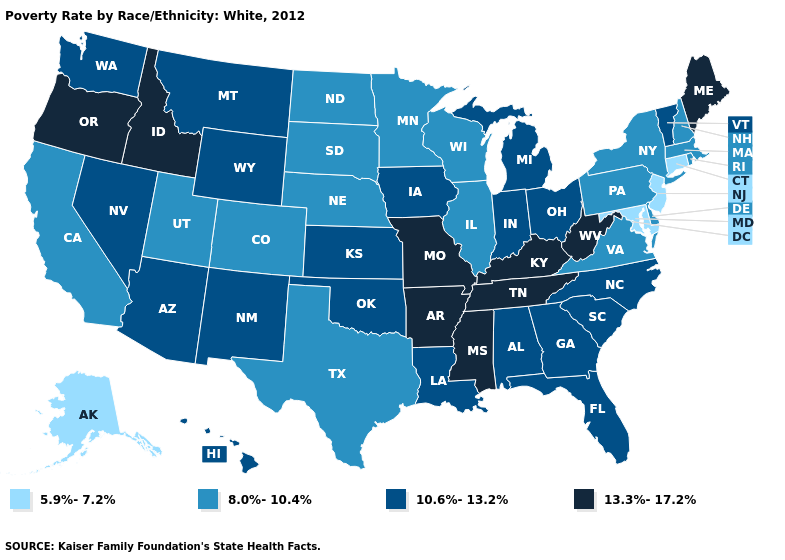Does New Jersey have the lowest value in the USA?
Keep it brief. Yes. Among the states that border Illinois , which have the lowest value?
Answer briefly. Wisconsin. Does Illinois have the same value as Louisiana?
Be succinct. No. Does Louisiana have the highest value in the USA?
Be succinct. No. What is the lowest value in states that border Ohio?
Quick response, please. 8.0%-10.4%. Name the states that have a value in the range 10.6%-13.2%?
Keep it brief. Alabama, Arizona, Florida, Georgia, Hawaii, Indiana, Iowa, Kansas, Louisiana, Michigan, Montana, Nevada, New Mexico, North Carolina, Ohio, Oklahoma, South Carolina, Vermont, Washington, Wyoming. What is the value of Michigan?
Write a very short answer. 10.6%-13.2%. Which states have the highest value in the USA?
Answer briefly. Arkansas, Idaho, Kentucky, Maine, Mississippi, Missouri, Oregon, Tennessee, West Virginia. What is the lowest value in the USA?
Be succinct. 5.9%-7.2%. Among the states that border Montana , which have the highest value?
Write a very short answer. Idaho. Does Wyoming have a lower value than Kentucky?
Concise answer only. Yes. Does the first symbol in the legend represent the smallest category?
Concise answer only. Yes. Name the states that have a value in the range 13.3%-17.2%?
Concise answer only. Arkansas, Idaho, Kentucky, Maine, Mississippi, Missouri, Oregon, Tennessee, West Virginia. Name the states that have a value in the range 8.0%-10.4%?
Short answer required. California, Colorado, Delaware, Illinois, Massachusetts, Minnesota, Nebraska, New Hampshire, New York, North Dakota, Pennsylvania, Rhode Island, South Dakota, Texas, Utah, Virginia, Wisconsin. 